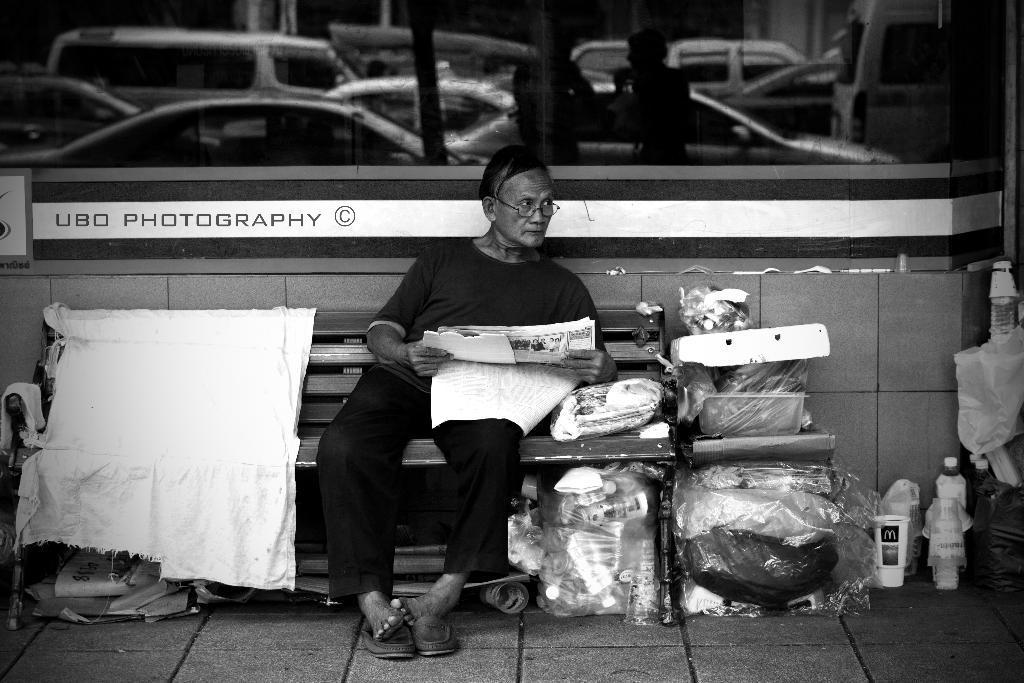Describe this image in one or two sentences. In this picture there is a man who is holding a paper and sitting on the bench. Beside him I can see the cloth, plastic covers, bottles and other objects. In the back I can see the glass partition and wall. In the glass reflection I can see many cars, poles and other objects. 